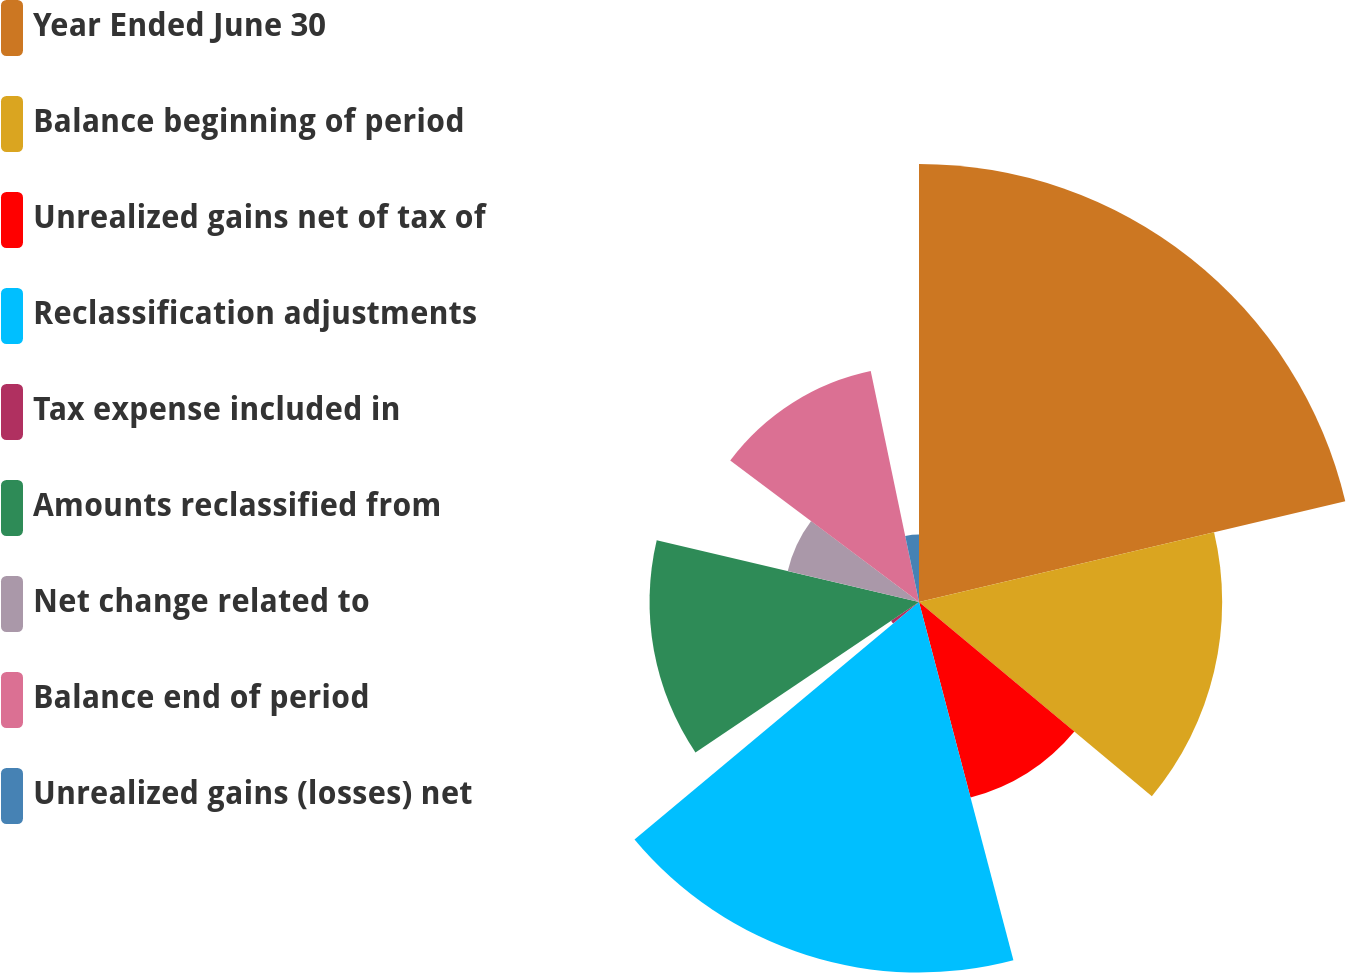Convert chart to OTSL. <chart><loc_0><loc_0><loc_500><loc_500><pie_chart><fcel>Year Ended June 30<fcel>Balance beginning of period<fcel>Unrealized gains net of tax of<fcel>Reclassification adjustments<fcel>Tax expense included in<fcel>Amounts reclassified from<fcel>Net change related to<fcel>Balance end of period<fcel>Unrealized gains (losses) net<nl><fcel>21.31%<fcel>14.75%<fcel>9.84%<fcel>18.03%<fcel>1.64%<fcel>13.11%<fcel>6.56%<fcel>11.48%<fcel>3.28%<nl></chart> 